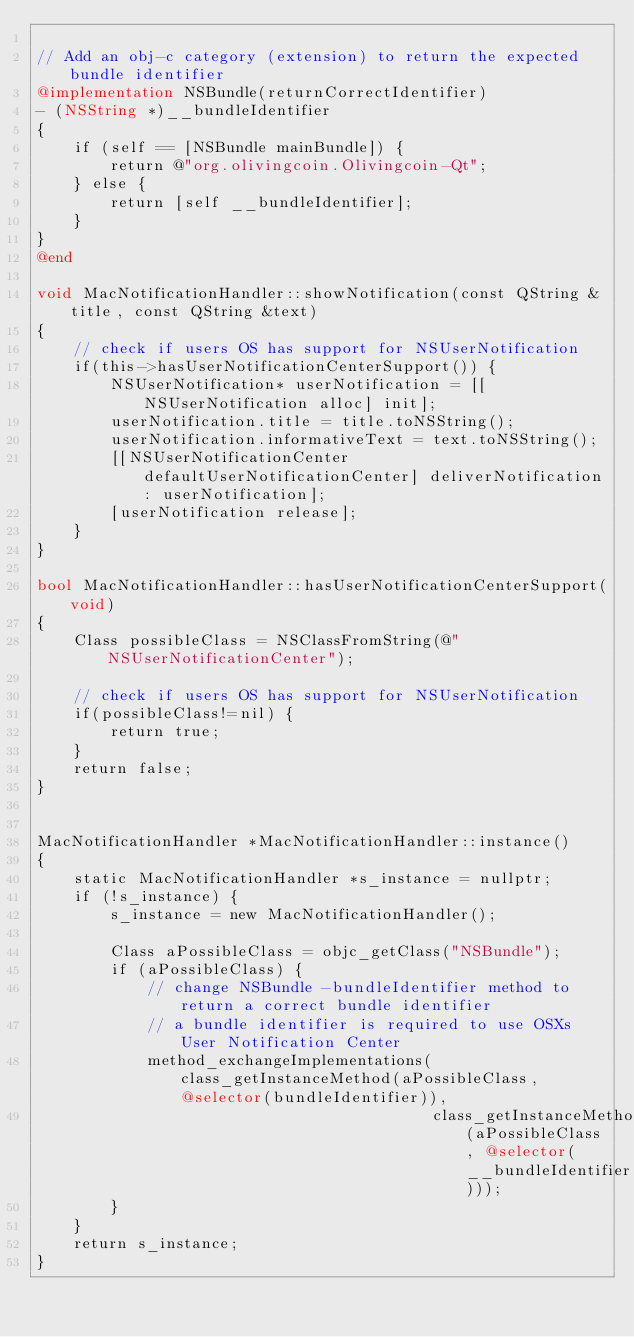Convert code to text. <code><loc_0><loc_0><loc_500><loc_500><_ObjectiveC_>
// Add an obj-c category (extension) to return the expected bundle identifier
@implementation NSBundle(returnCorrectIdentifier)
- (NSString *)__bundleIdentifier
{
    if (self == [NSBundle mainBundle]) {
        return @"org.olivingcoin.Olivingcoin-Qt";
    } else {
        return [self __bundleIdentifier];
    }
}
@end

void MacNotificationHandler::showNotification(const QString &title, const QString &text)
{
    // check if users OS has support for NSUserNotification
    if(this->hasUserNotificationCenterSupport()) {
        NSUserNotification* userNotification = [[NSUserNotification alloc] init];
        userNotification.title = title.toNSString();
        userNotification.informativeText = text.toNSString();
        [[NSUserNotificationCenter defaultUserNotificationCenter] deliverNotification: userNotification];
        [userNotification release];
    }
}

bool MacNotificationHandler::hasUserNotificationCenterSupport(void)
{
    Class possibleClass = NSClassFromString(@"NSUserNotificationCenter");

    // check if users OS has support for NSUserNotification
    if(possibleClass!=nil) {
        return true;
    }
    return false;
}


MacNotificationHandler *MacNotificationHandler::instance()
{
    static MacNotificationHandler *s_instance = nullptr;
    if (!s_instance) {
        s_instance = new MacNotificationHandler();

        Class aPossibleClass = objc_getClass("NSBundle");
        if (aPossibleClass) {
            // change NSBundle -bundleIdentifier method to return a correct bundle identifier
            // a bundle identifier is required to use OSXs User Notification Center
            method_exchangeImplementations(class_getInstanceMethod(aPossibleClass, @selector(bundleIdentifier)),
                                           class_getInstanceMethod(aPossibleClass, @selector(__bundleIdentifier)));
        }
    }
    return s_instance;
}
</code> 